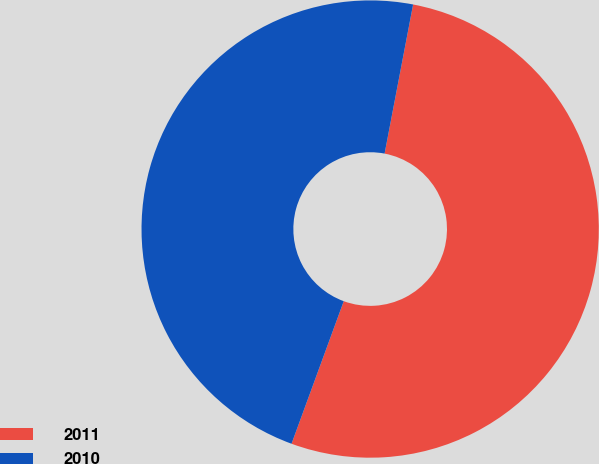Convert chart to OTSL. <chart><loc_0><loc_0><loc_500><loc_500><pie_chart><fcel>2011<fcel>2010<nl><fcel>52.58%<fcel>47.42%<nl></chart> 